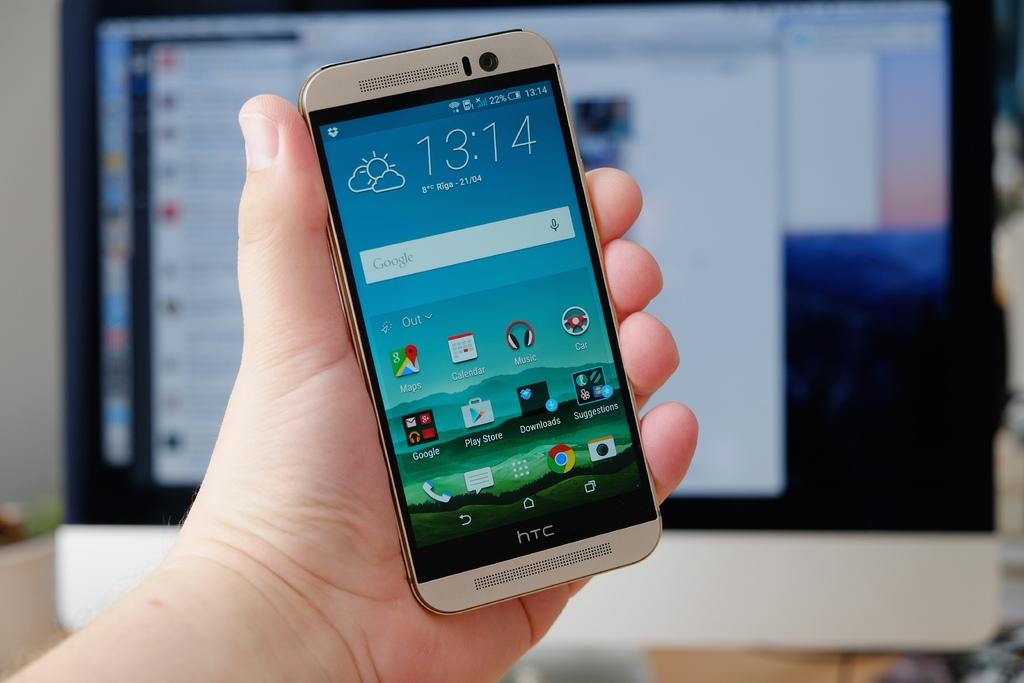Provide a one-sentence caption for the provided image. On April 21 it is 8 degrees Celsius in Riga. 